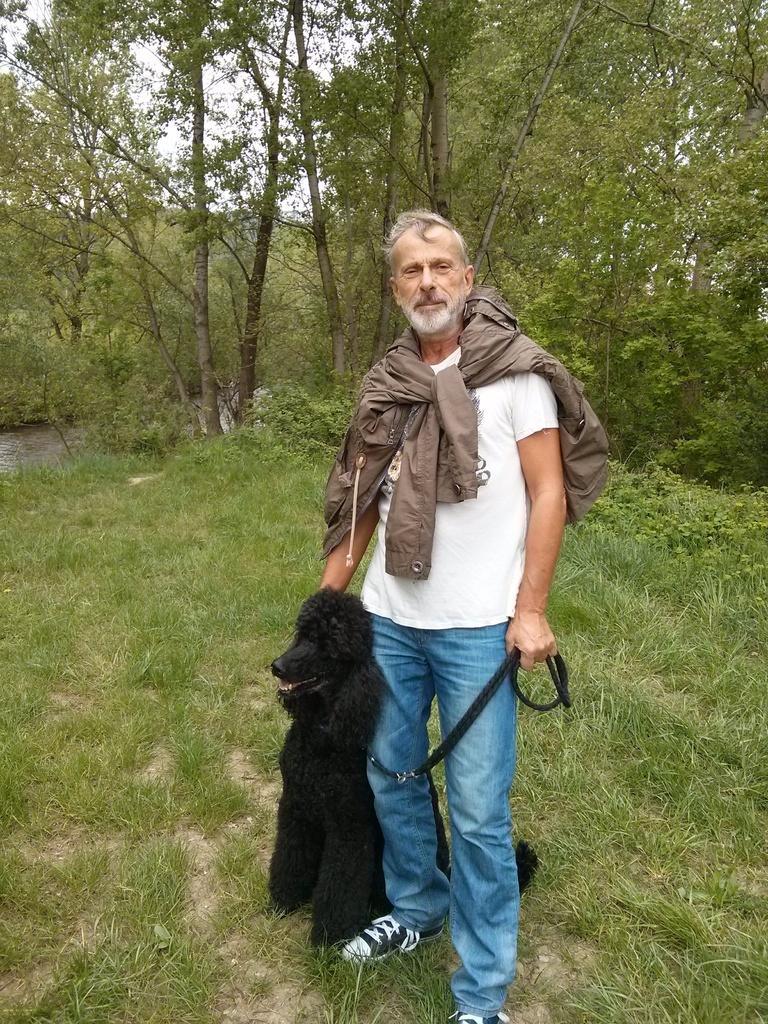Please provide a concise description of this image. In this picture we can see man wore white color T-Shirt, jacket to his neck and holding dog with his hand and in the background we can see tree, sky. 